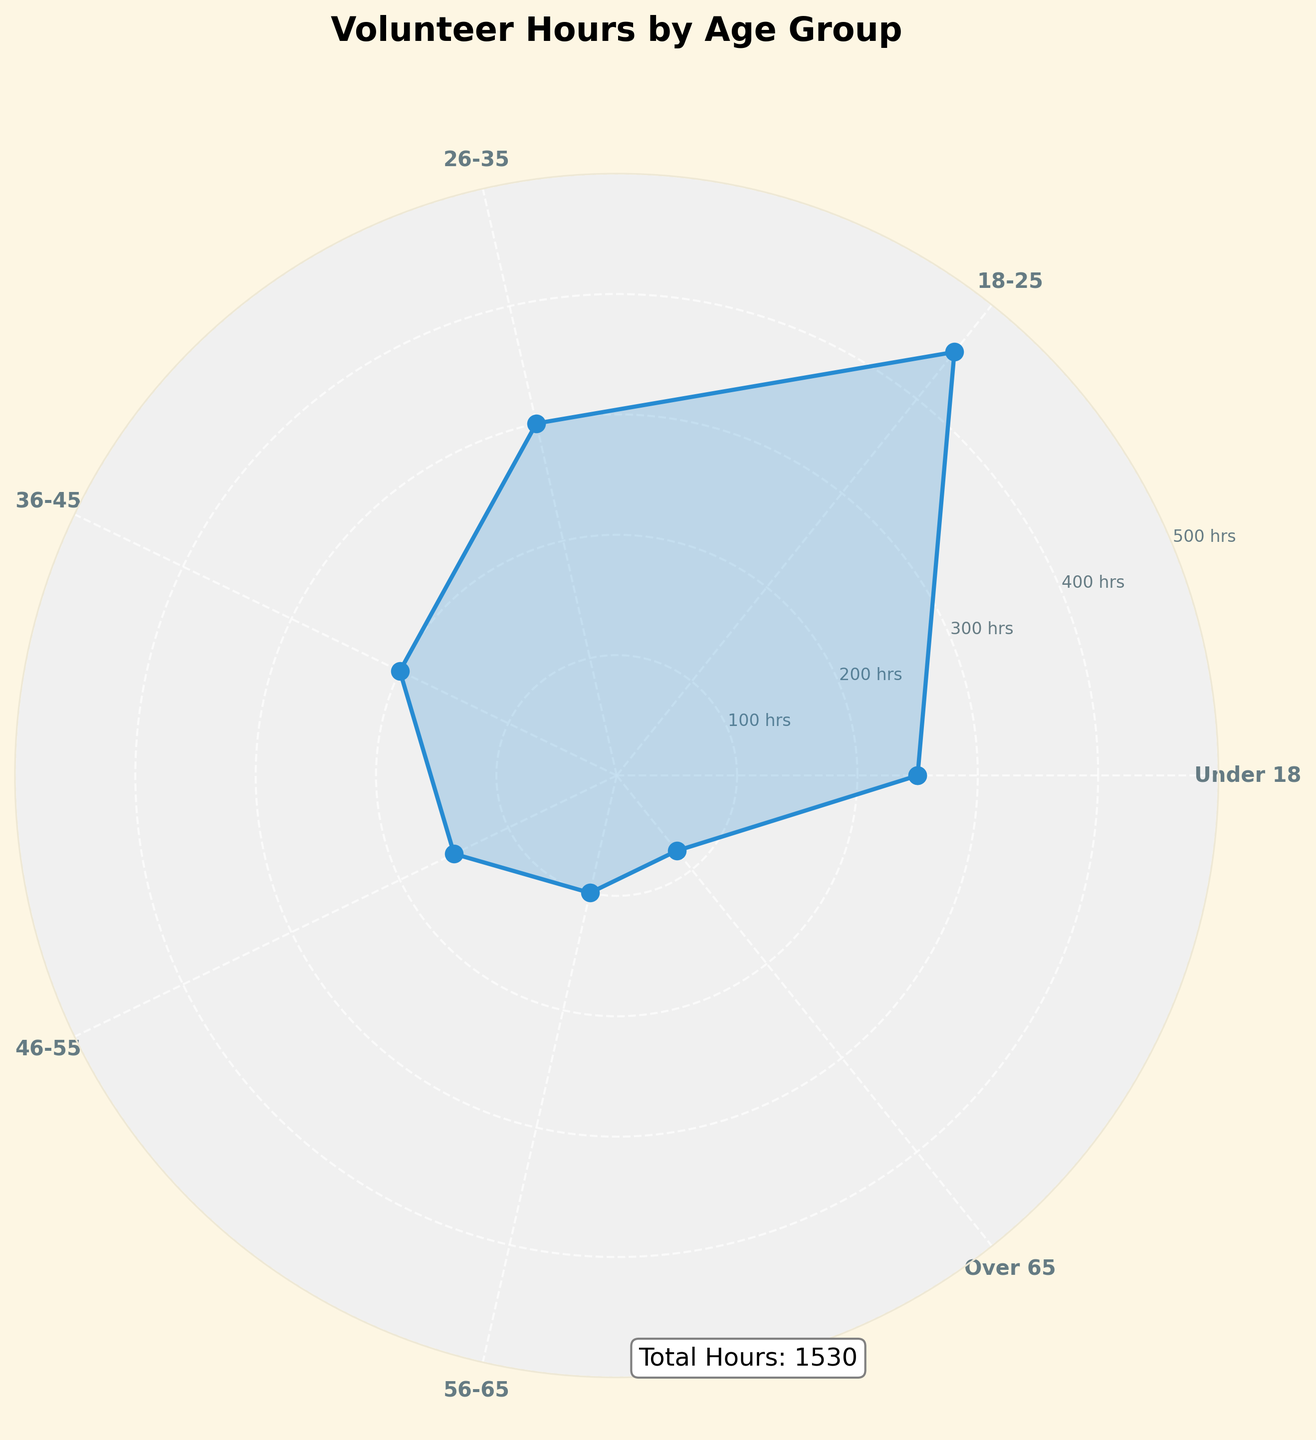How many age groups are represented in the plot? By examining the number of labels on the x-axis of the polar area chart, you can count the total number of age groups.
Answer: 7 Which age group contributed the most volunteer hours? Identify the segment with the longest radial length on the polar area chart, which represents the age group with the highest value in volunteer hours.
Answer: 18-25 Which age group contributed the fewest volunteer hours? Look for the segment with the shortest radial length on the polar area chart to identify the age group with the smallest volunteer hours.
Answer: Over 65 What is the title of the figure? The title of the figure is typically located at the top of the chart, clearly stating the subject of the plot.
Answer: Volunteer Hours by Age Group What is the total combined volunteer hours of the Under 18 and 56-65 age groups? Sum the volunteer hours of the Under 18 and 56-65 age groups by adding their radial lengths: 250 (Under 18) + 100 (56-65) = 350.
Answer: 350 How does the volunteer contribution of the 26-35 age group compare to the 46-55 age group? Compare the radial lengths of the 26-35 and 46-55 segments. The 26-35 group has a longer radial segment (300 hours) compared to the 46-55 group (150 hours).
Answer: 26-35 contributed more What is the difference between the volunteer hours of the 18-25 age group and the 36-45 age group? Subtract the volunteer hours of the 36-45 age group from the 18-25 age group: 450 (18-25) - 200 (36-45) = 250.
Answer: 250 What is the second highest age group in terms of volunteer hours? Identify the second longest radial segment after the 18-25 age group; it is the Under 18 group, with 250 hours.
Answer: Under 18 How are the angles distributed for each age group segment? The angular distribution is calculated by dividing 360 degrees (or 2π radians) evenly among the 7 age groups represented. Each group occupies an angle of approximately 51.43 degrees (2π/7).
Answer: Even distribution, approximately 51.43 degrees per group Does the plot indicate the total number of volunteer hours contributed? Examine the annotations or labels on the chart; the plot includes an annotation text at the bottom stating the total volunteer hours: 'Total Hours: 1530’.
Answer: Yes, 1530 